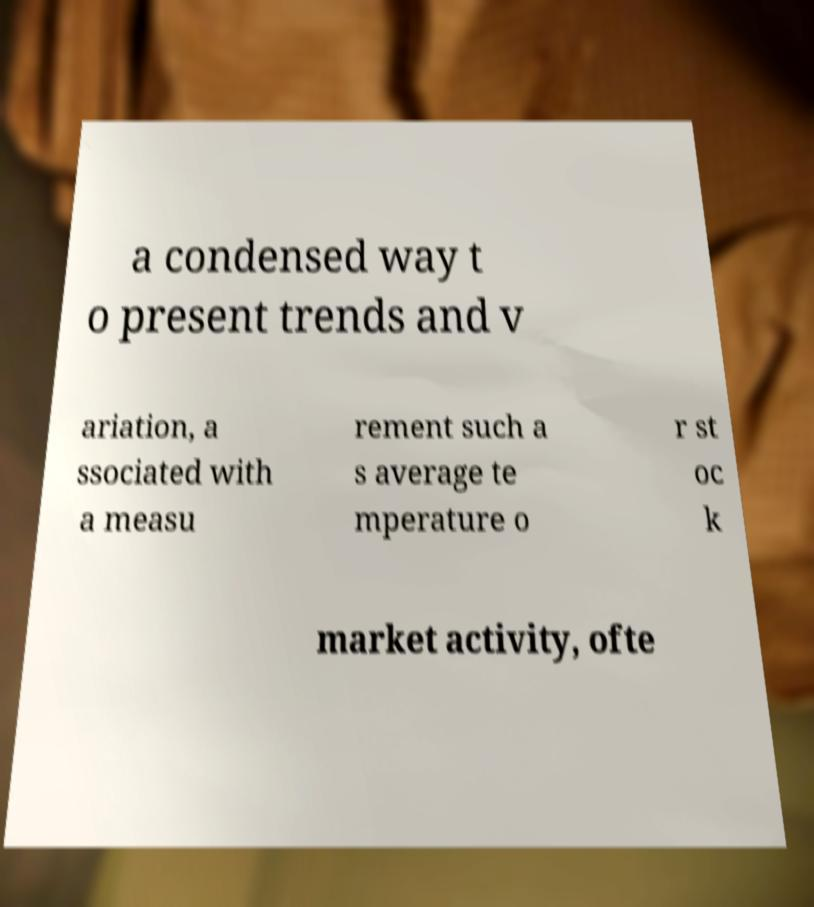What messages or text are displayed in this image? I need them in a readable, typed format. a condensed way t o present trends and v ariation, a ssociated with a measu rement such a s average te mperature o r st oc k market activity, ofte 